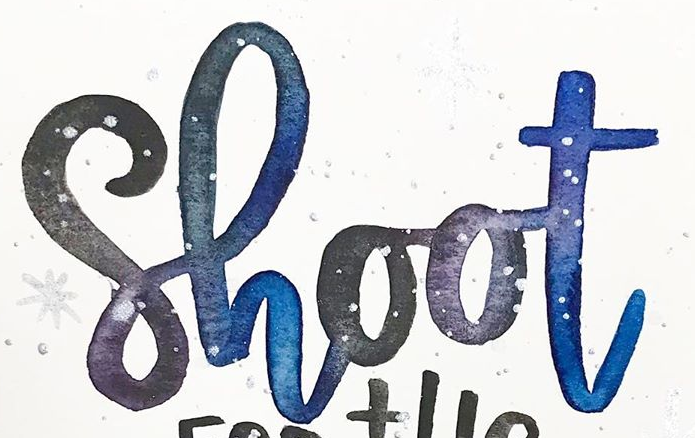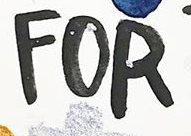What text appears in these images from left to right, separated by a semicolon? Shoot; FOR 